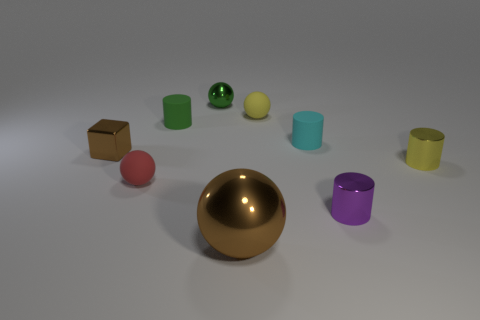What number of cylinders are green matte things or small yellow matte objects?
Give a very brief answer. 1. The small matte object that is to the right of the matte ball right of the large shiny ball is what color?
Make the answer very short. Cyan. What is the size of the ball that is the same color as the small block?
Your answer should be compact. Large. What number of small yellow things are to the left of the cylinder that is in front of the tiny ball that is in front of the tiny cyan cylinder?
Ensure brevity in your answer.  1. Do the green thing in front of the tiny green metal ball and the brown thing that is behind the large brown shiny sphere have the same shape?
Offer a very short reply. No. What number of things are either large metallic objects or yellow metal objects?
Make the answer very short. 2. The brown object on the left side of the metal sphere that is behind the big shiny sphere is made of what material?
Offer a very short reply. Metal. Is there a tiny metallic ball of the same color as the block?
Your response must be concise. No. There is a matte sphere that is the same size as the red thing; what color is it?
Give a very brief answer. Yellow. What is the ball to the left of the tiny green thing to the left of the tiny metal sphere that is to the left of the small purple metallic thing made of?
Offer a very short reply. Rubber. 